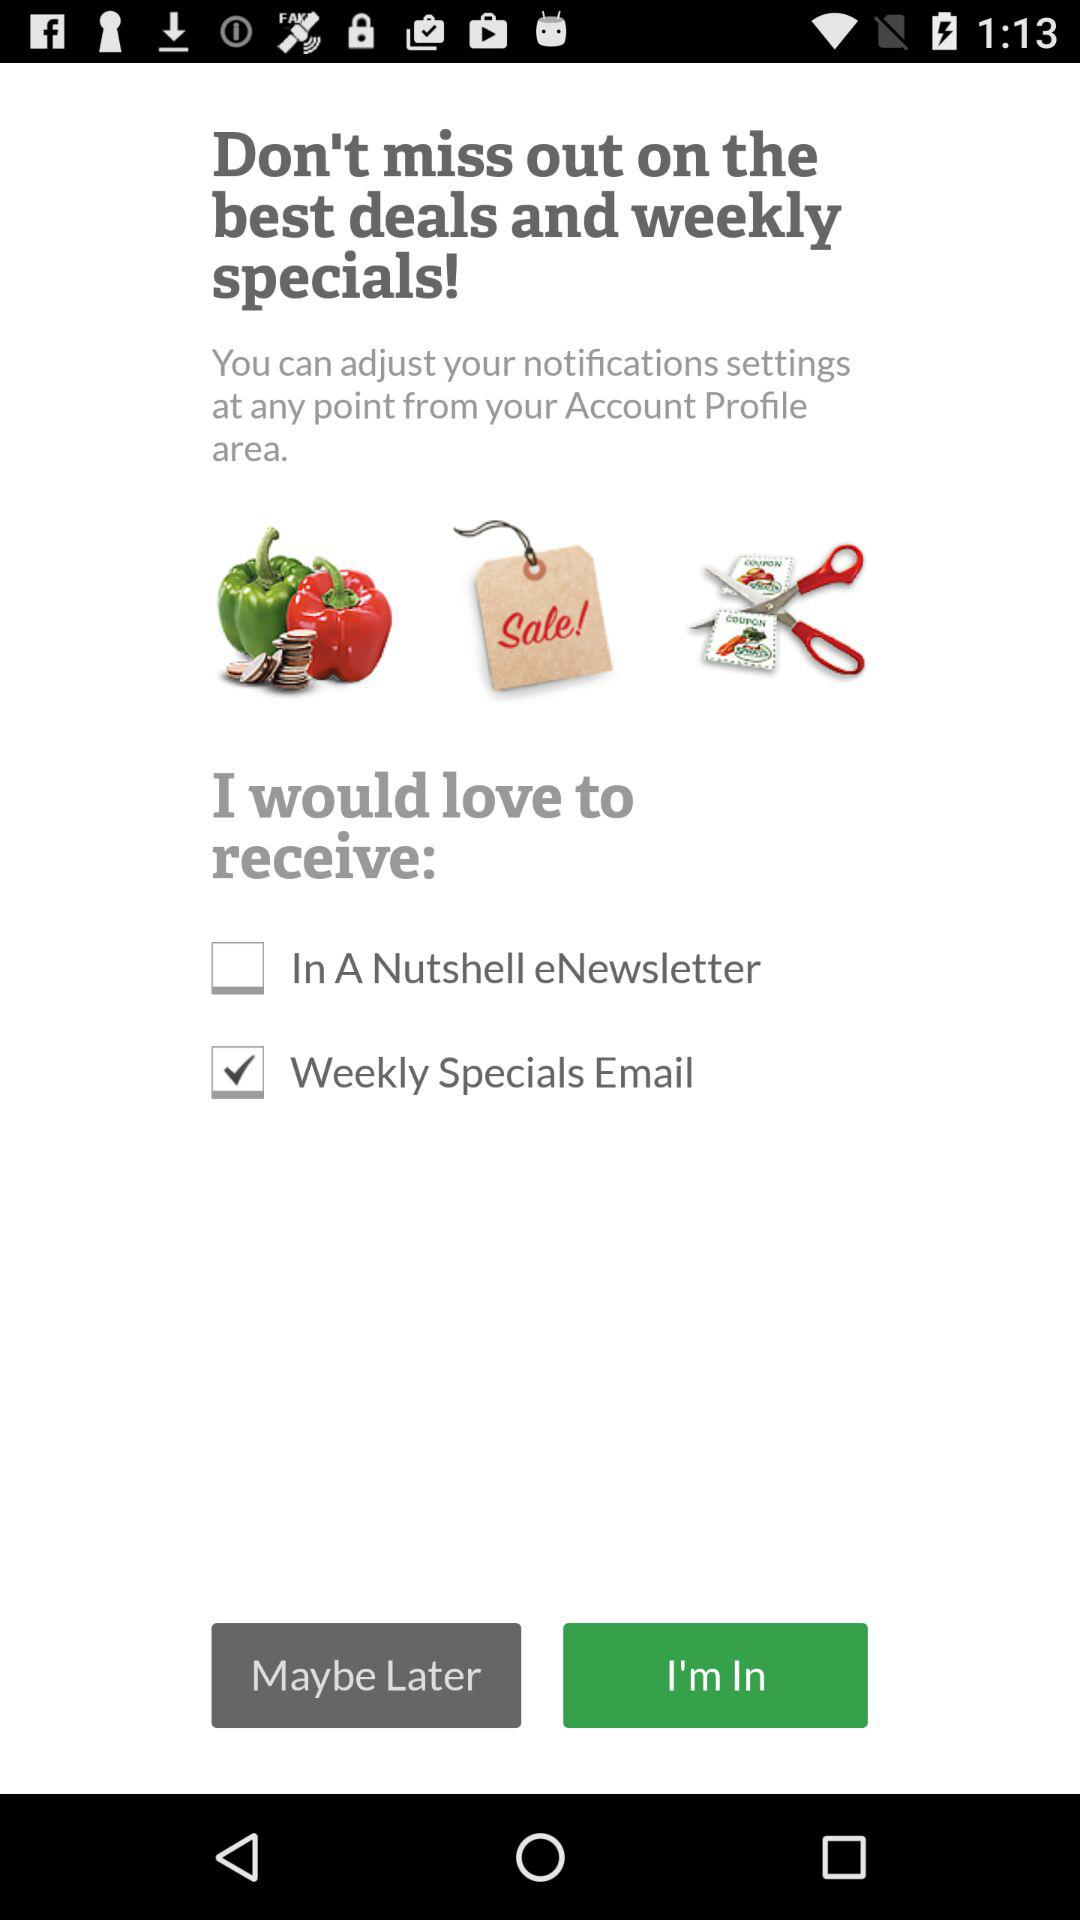What is the status of the "Weekly Specials Email"? The status is on. 